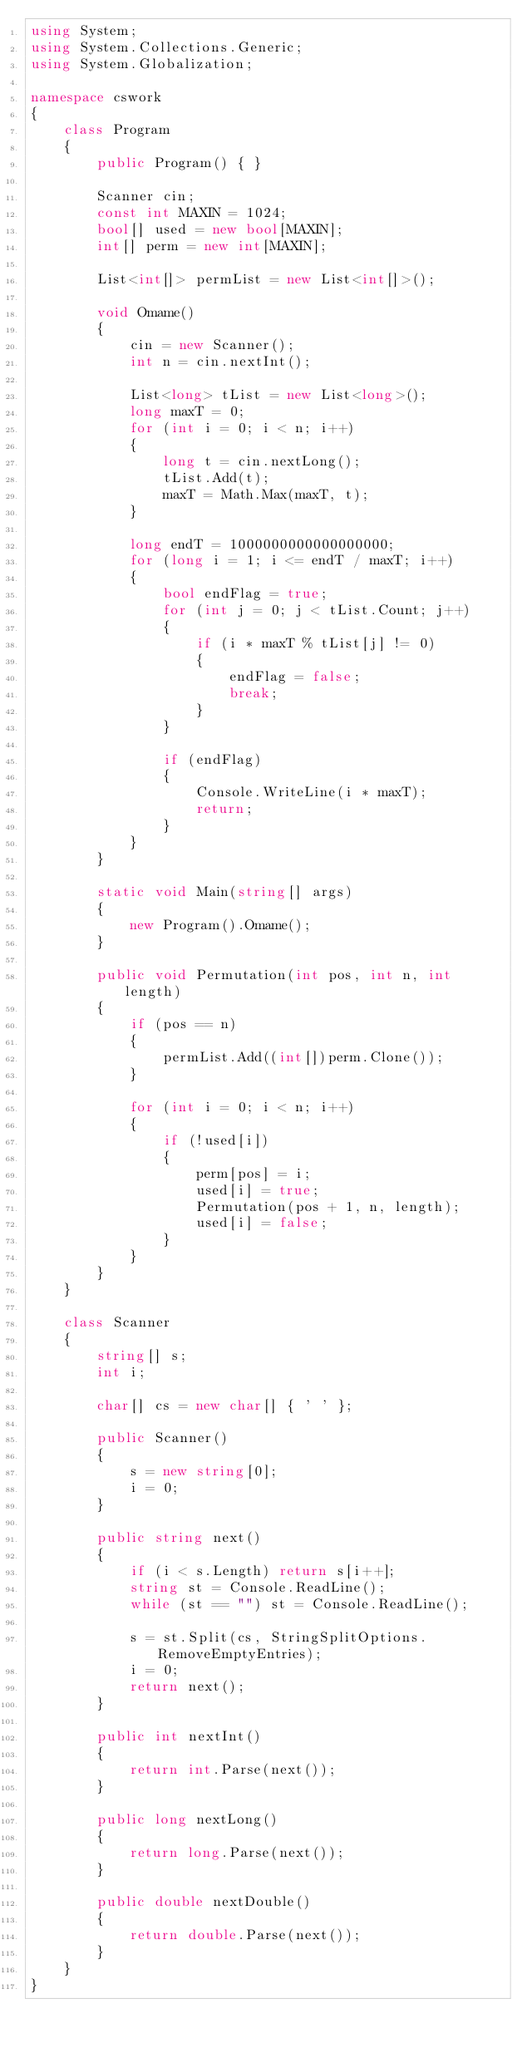Convert code to text. <code><loc_0><loc_0><loc_500><loc_500><_C#_>using System;
using System.Collections.Generic;
using System.Globalization;

namespace cswork
{
    class Program
    {
        public Program() { }

        Scanner cin;
        const int MAXIN = 1024;
        bool[] used = new bool[MAXIN];
        int[] perm = new int[MAXIN];

        List<int[]> permList = new List<int[]>();

        void Omame()
        {
            cin = new Scanner();
            int n = cin.nextInt();

            List<long> tList = new List<long>();
            long maxT = 0;
            for (int i = 0; i < n; i++)
            {
                long t = cin.nextLong();
                tList.Add(t);
                maxT = Math.Max(maxT, t);
            }

            long endT = 1000000000000000000;
            for (long i = 1; i <= endT / maxT; i++)
            {
                bool endFlag = true;
                for (int j = 0; j < tList.Count; j++)
                {
                    if (i * maxT % tList[j] != 0)
                    {
                        endFlag = false;
                        break;
                    }
                }

                if (endFlag)
                {
                    Console.WriteLine(i * maxT);
                    return;
                }
            }
        }

        static void Main(string[] args)
        {
            new Program().Omame();
        }

        public void Permutation(int pos, int n, int length)
        {
            if (pos == n)
            {
                permList.Add((int[])perm.Clone());
            }

            for (int i = 0; i < n; i++)
            {
                if (!used[i])
                {
                    perm[pos] = i;
                    used[i] = true;
                    Permutation(pos + 1, n, length);
                    used[i] = false;
                }
            }
        }
    }

    class Scanner
    {
        string[] s;
        int i;

        char[] cs = new char[] { ' ' };

        public Scanner()
        {
            s = new string[0];
            i = 0;
        }

        public string next()
        {
            if (i < s.Length) return s[i++];
            string st = Console.ReadLine();
            while (st == "") st = Console.ReadLine();

            s = st.Split(cs, StringSplitOptions.RemoveEmptyEntries);
            i = 0;
            return next();
        }

        public int nextInt()
        {
            return int.Parse(next());
        }

        public long nextLong()
        {
            return long.Parse(next());
        }

        public double nextDouble()
        {
            return double.Parse(next());
        }
    }
}</code> 